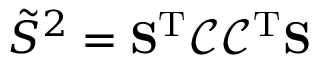Convert formula to latex. <formula><loc_0><loc_0><loc_500><loc_500>\tilde { S } ^ { 2 } = S ^ { T } \mathcal { C } \mathcal { C } ^ { T } S</formula> 